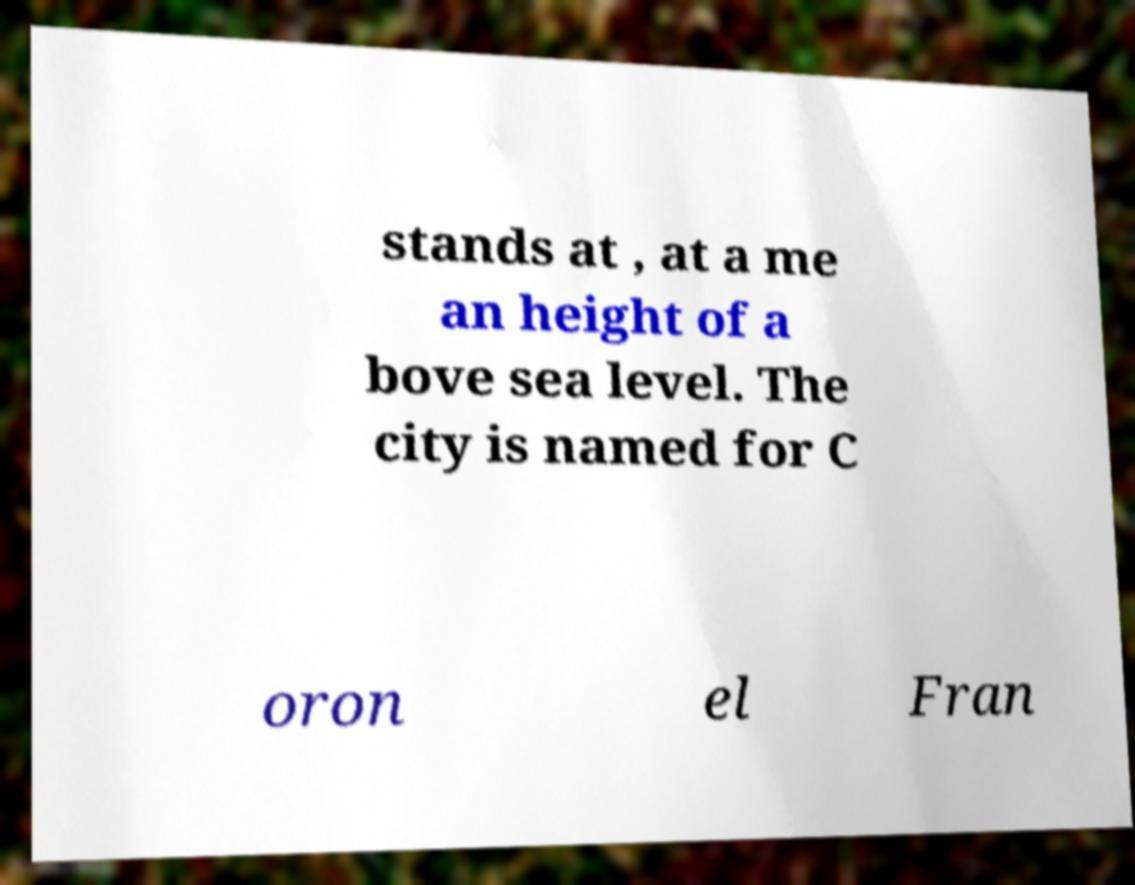There's text embedded in this image that I need extracted. Can you transcribe it verbatim? stands at , at a me an height of a bove sea level. The city is named for C oron el Fran 